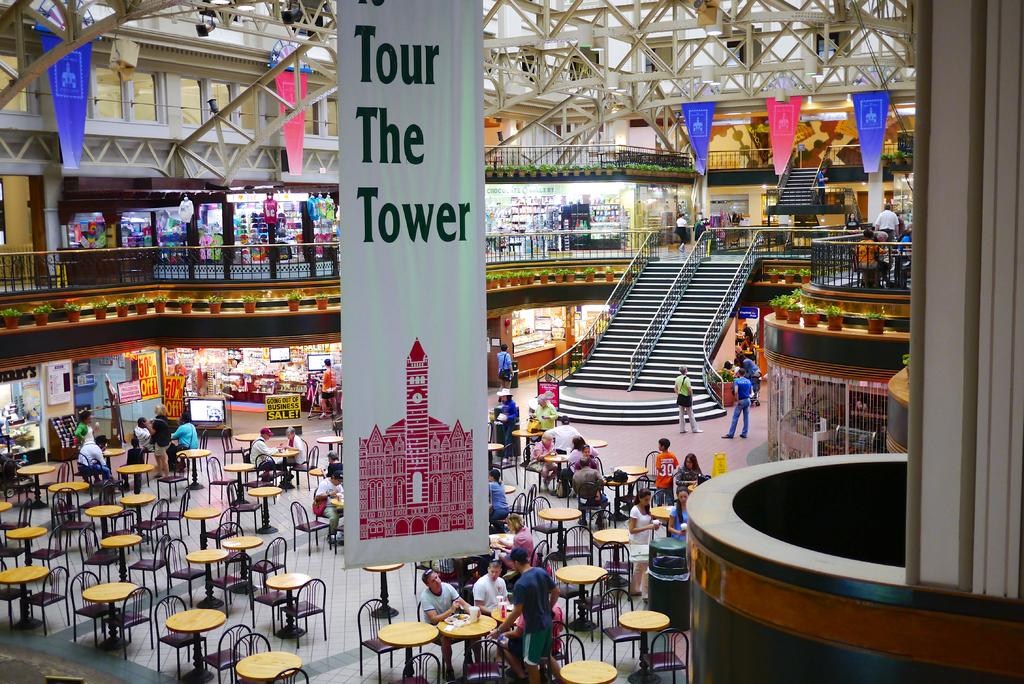Provide a one-sentence caption for the provided image. A banner that reads "Tour The Tower" hangs above a large restaurant area in the mall. 